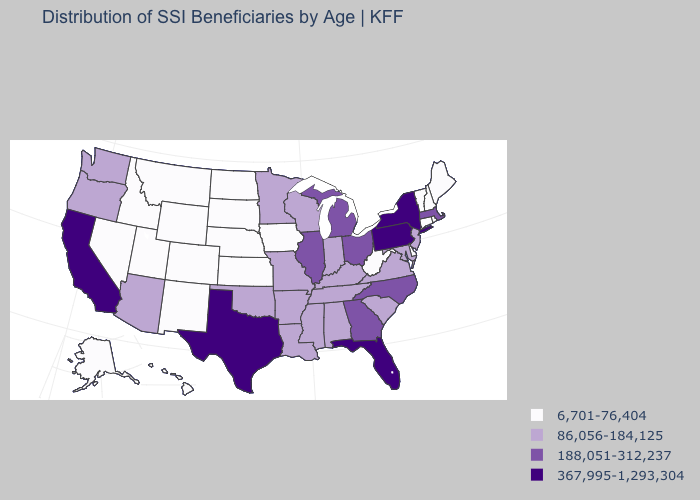What is the value of Maryland?
Be succinct. 86,056-184,125. Which states have the lowest value in the USA?
Answer briefly. Alaska, Colorado, Connecticut, Delaware, Hawaii, Idaho, Iowa, Kansas, Maine, Montana, Nebraska, Nevada, New Hampshire, New Mexico, North Dakota, Rhode Island, South Dakota, Utah, Vermont, West Virginia, Wyoming. Name the states that have a value in the range 6,701-76,404?
Short answer required. Alaska, Colorado, Connecticut, Delaware, Hawaii, Idaho, Iowa, Kansas, Maine, Montana, Nebraska, Nevada, New Hampshire, New Mexico, North Dakota, Rhode Island, South Dakota, Utah, Vermont, West Virginia, Wyoming. Name the states that have a value in the range 86,056-184,125?
Quick response, please. Alabama, Arizona, Arkansas, Indiana, Kentucky, Louisiana, Maryland, Minnesota, Mississippi, Missouri, New Jersey, Oklahoma, Oregon, South Carolina, Tennessee, Virginia, Washington, Wisconsin. Name the states that have a value in the range 367,995-1,293,304?
Keep it brief. California, Florida, New York, Pennsylvania, Texas. What is the lowest value in states that border New Jersey?
Keep it brief. 6,701-76,404. Which states hav the highest value in the South?
Keep it brief. Florida, Texas. Does the first symbol in the legend represent the smallest category?
Short answer required. Yes. Which states have the lowest value in the MidWest?
Be succinct. Iowa, Kansas, Nebraska, North Dakota, South Dakota. Does Illinois have a lower value than New York?
Write a very short answer. Yes. Name the states that have a value in the range 86,056-184,125?
Short answer required. Alabama, Arizona, Arkansas, Indiana, Kentucky, Louisiana, Maryland, Minnesota, Mississippi, Missouri, New Jersey, Oklahoma, Oregon, South Carolina, Tennessee, Virginia, Washington, Wisconsin. Does Wyoming have the lowest value in the West?
Short answer required. Yes. Does West Virginia have a lower value than Utah?
Be succinct. No. Among the states that border Mississippi , which have the highest value?
Write a very short answer. Alabama, Arkansas, Louisiana, Tennessee. Among the states that border Georgia , which have the lowest value?
Quick response, please. Alabama, South Carolina, Tennessee. 